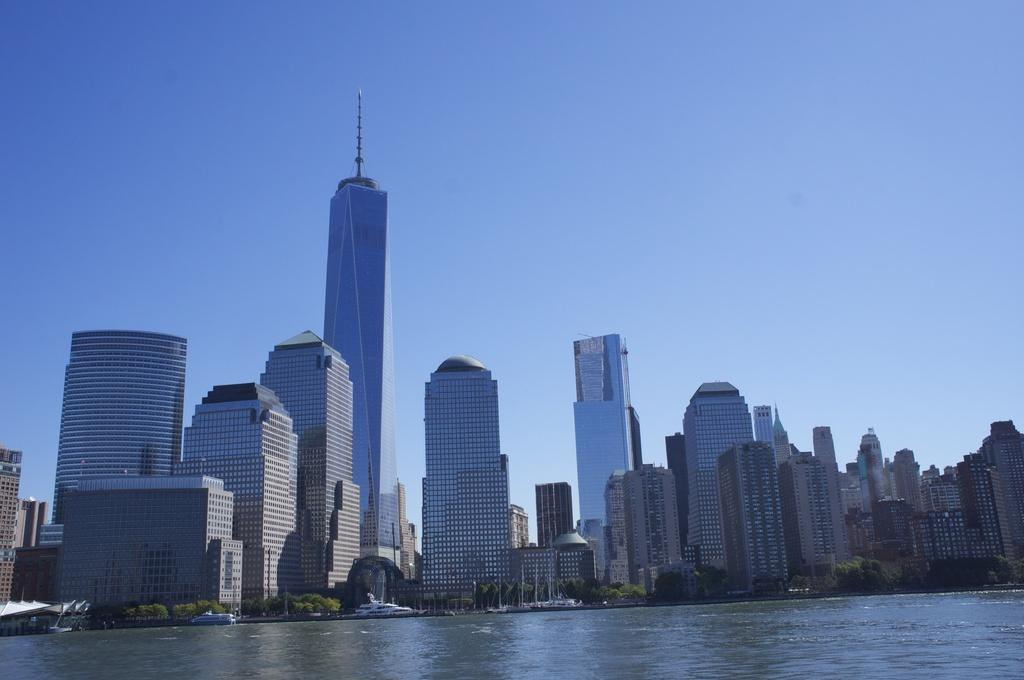What type of structures can be seen in the image? There are buildings in the image. What other natural elements are present in the image? There are trees and water visible in the image. What part of the natural environment is visible in the image? The sky is visible in the image. Can you tell me which doctor is treating the patient in the image? There is no doctor or patient present in the image; it features buildings, trees, water, and the sky. 